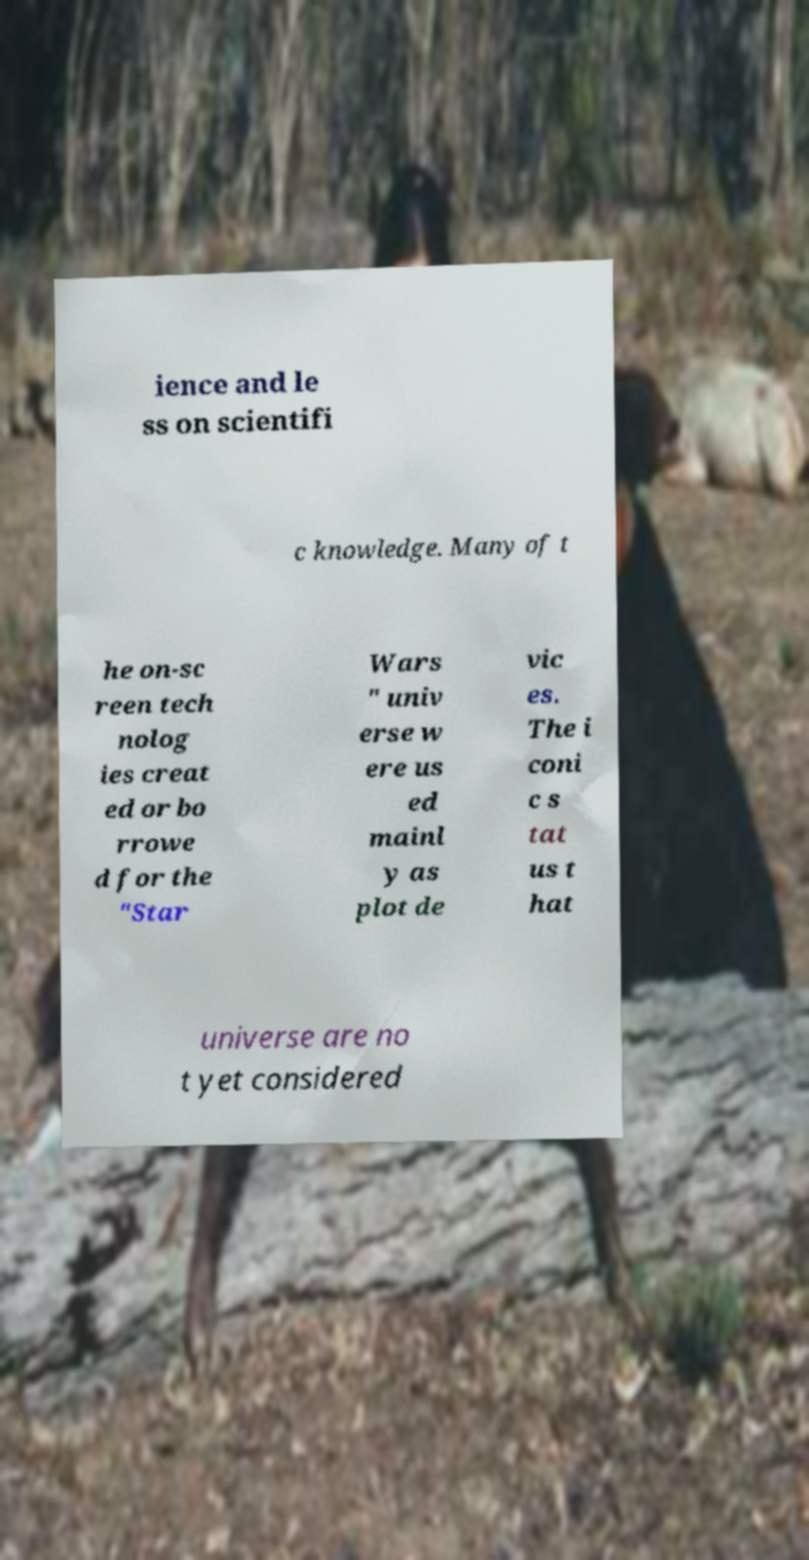Could you extract and type out the text from this image? ience and le ss on scientifi c knowledge. Many of t he on-sc reen tech nolog ies creat ed or bo rrowe d for the "Star Wars " univ erse w ere us ed mainl y as plot de vic es. The i coni c s tat us t hat universe are no t yet considered 